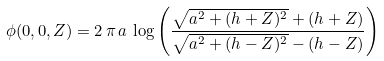Convert formula to latex. <formula><loc_0><loc_0><loc_500><loc_500>\phi ( 0 , 0 , Z ) = 2 \, \pi \, a \, \log \left ( \frac { \sqrt { a ^ { 2 } + ( h + Z ) ^ { 2 } } + ( h + Z ) } { \sqrt { a ^ { 2 } + ( h - Z ) ^ { 2 } } - ( h - Z ) } \right )</formula> 